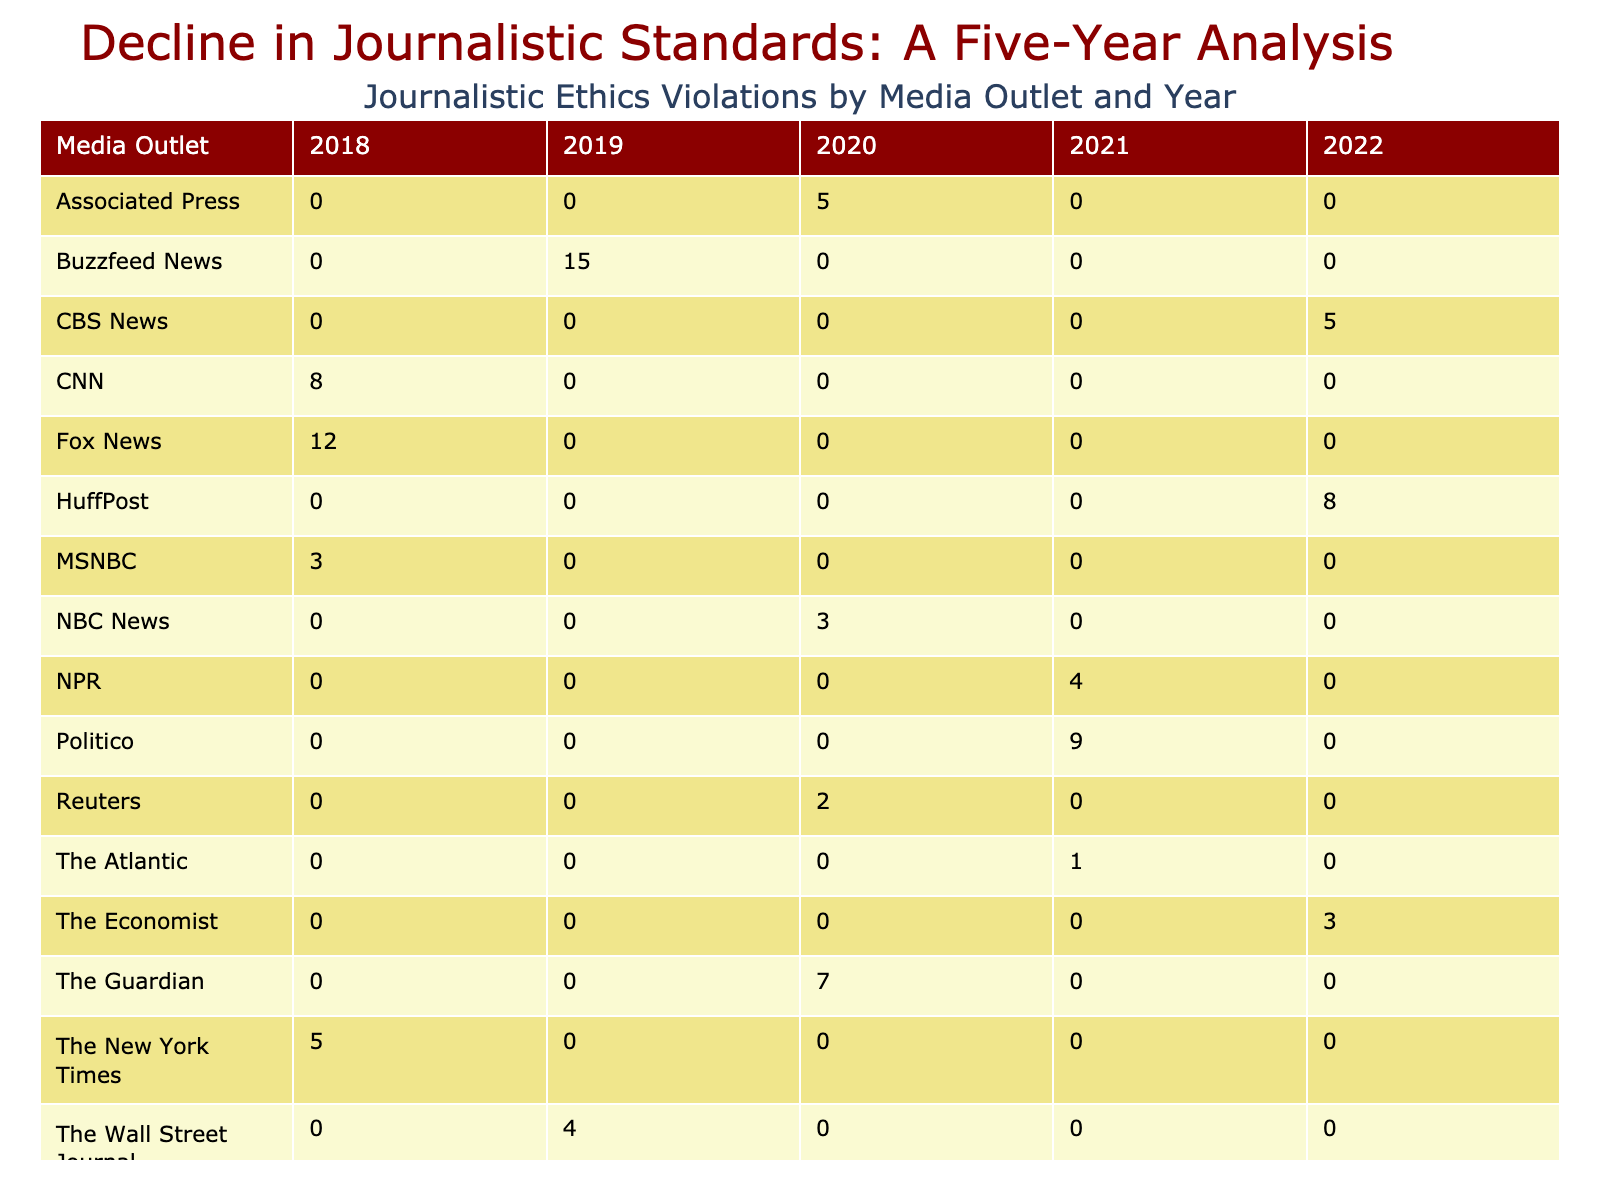What is the highest number of incidents reported in a single year for any media outlet? Examining the table, the maximum value in the “Number of Incidents” column is 15, which corresponds to the year 2019 for Buzzfeed News.
Answer: 15 Which media outlet had the most incidents in 2021? In 2021, Vox had 11 incidents, which is more than any other media outlet that year as shown in the table.
Answer: Vox Did any media outlet report a "Plagiarism" violation in 2022? The table shows that there were no incidents of "Plagiarism" reported in 2022, meaning the answer is false.
Answer: No How many total incidents of "Biased Reporting" were reported across all years and media outlets? Summing the incidents for "Biased Reporting" from 2018 (12), 2020 (5), 2022 (8) gives a total of 12 + 5 + 8 = 25.
Answer: 25 Which year had the highest total number of incidents across all media outlets? Adding up all incidents by year: 2018 (28), 2019 (27), 2020 (17), 2021 (24), 2022 (18). The highest total is in 2018, with 28 incidents.
Answer: 2018 How many incidents of "Factual Error" were reported in total from 2018 to 2022? From the table, the incidents for "Factual Error" are: 5 in 2018, 7 in 2020, and 3 in 2022, resulting in a total of 5 + 7 + 3 = 15 incidents.
Answer: 15 Was there any year where the number of incidents for "Conflict of Interest" exceeded that of "Privacy Invasion"? Looking at the table, "Conflict of Interest" has 3 incidents in 2018 and 2 in 2020, while "Privacy Invasion" has 0 in 2018 and 2 in 2022. There is no year with more for "Conflict of Interest".
Answer: No What was the average number of incidents per year for the media outlet "NBC News"? NBC News had incidents in 2020 (3) and none in other years, resulting in an average of 3 incidents/1 year = 3.
Answer: 3 In which year did "Clickbait Headlines" have its highest number of incidents, and how many was it? According to the table, "Clickbait Headlines" had its highest number of incidents in 2019 with 15, the only year it was reported.
Answer: 2019, 15 